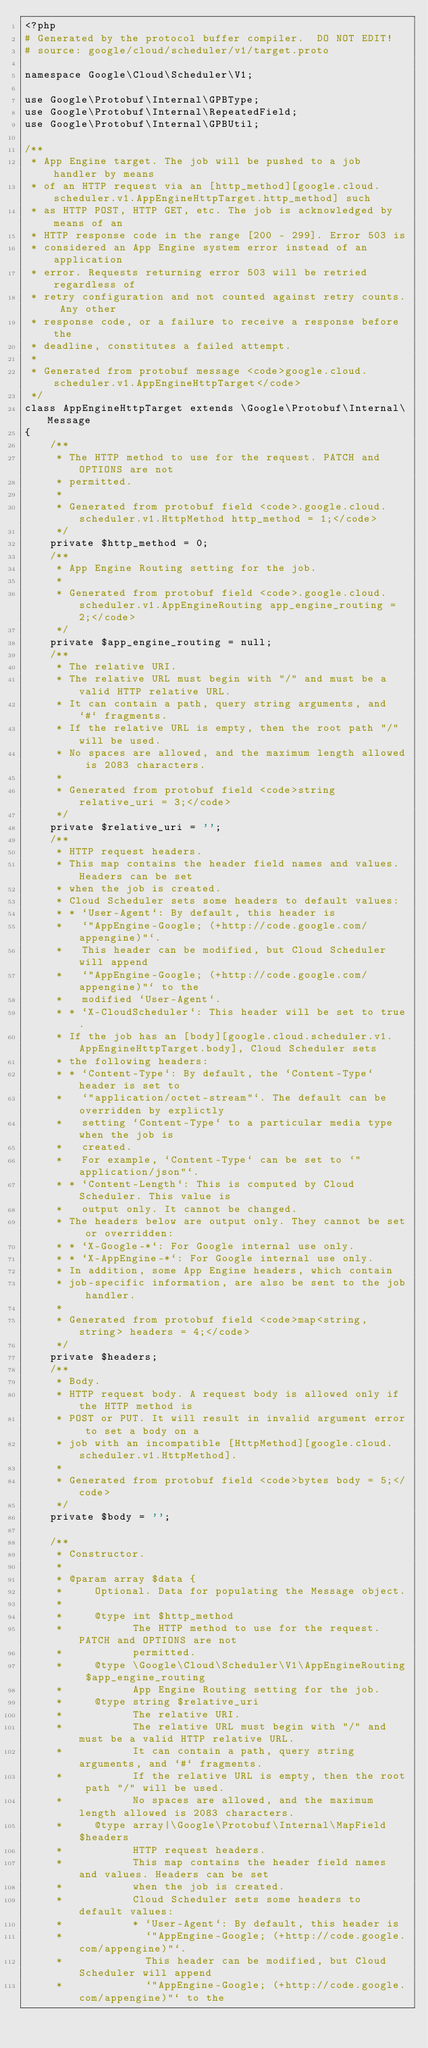Convert code to text. <code><loc_0><loc_0><loc_500><loc_500><_PHP_><?php
# Generated by the protocol buffer compiler.  DO NOT EDIT!
# source: google/cloud/scheduler/v1/target.proto

namespace Google\Cloud\Scheduler\V1;

use Google\Protobuf\Internal\GPBType;
use Google\Protobuf\Internal\RepeatedField;
use Google\Protobuf\Internal\GPBUtil;

/**
 * App Engine target. The job will be pushed to a job handler by means
 * of an HTTP request via an [http_method][google.cloud.scheduler.v1.AppEngineHttpTarget.http_method] such
 * as HTTP POST, HTTP GET, etc. The job is acknowledged by means of an
 * HTTP response code in the range [200 - 299]. Error 503 is
 * considered an App Engine system error instead of an application
 * error. Requests returning error 503 will be retried regardless of
 * retry configuration and not counted against retry counts. Any other
 * response code, or a failure to receive a response before the
 * deadline, constitutes a failed attempt.
 *
 * Generated from protobuf message <code>google.cloud.scheduler.v1.AppEngineHttpTarget</code>
 */
class AppEngineHttpTarget extends \Google\Protobuf\Internal\Message
{
    /**
     * The HTTP method to use for the request. PATCH and OPTIONS are not
     * permitted.
     *
     * Generated from protobuf field <code>.google.cloud.scheduler.v1.HttpMethod http_method = 1;</code>
     */
    private $http_method = 0;
    /**
     * App Engine Routing setting for the job.
     *
     * Generated from protobuf field <code>.google.cloud.scheduler.v1.AppEngineRouting app_engine_routing = 2;</code>
     */
    private $app_engine_routing = null;
    /**
     * The relative URI.
     * The relative URL must begin with "/" and must be a valid HTTP relative URL.
     * It can contain a path, query string arguments, and `#` fragments.
     * If the relative URL is empty, then the root path "/" will be used.
     * No spaces are allowed, and the maximum length allowed is 2083 characters.
     *
     * Generated from protobuf field <code>string relative_uri = 3;</code>
     */
    private $relative_uri = '';
    /**
     * HTTP request headers.
     * This map contains the header field names and values. Headers can be set
     * when the job is created.
     * Cloud Scheduler sets some headers to default values:
     * * `User-Agent`: By default, this header is
     *   `"AppEngine-Google; (+http://code.google.com/appengine)"`.
     *   This header can be modified, but Cloud Scheduler will append
     *   `"AppEngine-Google; (+http://code.google.com/appengine)"` to the
     *   modified `User-Agent`.
     * * `X-CloudScheduler`: This header will be set to true.
     * If the job has an [body][google.cloud.scheduler.v1.AppEngineHttpTarget.body], Cloud Scheduler sets
     * the following headers:
     * * `Content-Type`: By default, the `Content-Type` header is set to
     *   `"application/octet-stream"`. The default can be overridden by explictly
     *   setting `Content-Type` to a particular media type when the job is
     *   created.
     *   For example, `Content-Type` can be set to `"application/json"`.
     * * `Content-Length`: This is computed by Cloud Scheduler. This value is
     *   output only. It cannot be changed.
     * The headers below are output only. They cannot be set or overridden:
     * * `X-Google-*`: For Google internal use only.
     * * `X-AppEngine-*`: For Google internal use only.
     * In addition, some App Engine headers, which contain
     * job-specific information, are also be sent to the job handler.
     *
     * Generated from protobuf field <code>map<string, string> headers = 4;</code>
     */
    private $headers;
    /**
     * Body.
     * HTTP request body. A request body is allowed only if the HTTP method is
     * POST or PUT. It will result in invalid argument error to set a body on a
     * job with an incompatible [HttpMethod][google.cloud.scheduler.v1.HttpMethod].
     *
     * Generated from protobuf field <code>bytes body = 5;</code>
     */
    private $body = '';

    /**
     * Constructor.
     *
     * @param array $data {
     *     Optional. Data for populating the Message object.
     *
     *     @type int $http_method
     *           The HTTP method to use for the request. PATCH and OPTIONS are not
     *           permitted.
     *     @type \Google\Cloud\Scheduler\V1\AppEngineRouting $app_engine_routing
     *           App Engine Routing setting for the job.
     *     @type string $relative_uri
     *           The relative URI.
     *           The relative URL must begin with "/" and must be a valid HTTP relative URL.
     *           It can contain a path, query string arguments, and `#` fragments.
     *           If the relative URL is empty, then the root path "/" will be used.
     *           No spaces are allowed, and the maximum length allowed is 2083 characters.
     *     @type array|\Google\Protobuf\Internal\MapField $headers
     *           HTTP request headers.
     *           This map contains the header field names and values. Headers can be set
     *           when the job is created.
     *           Cloud Scheduler sets some headers to default values:
     *           * `User-Agent`: By default, this header is
     *             `"AppEngine-Google; (+http://code.google.com/appengine)"`.
     *             This header can be modified, but Cloud Scheduler will append
     *             `"AppEngine-Google; (+http://code.google.com/appengine)"` to the</code> 